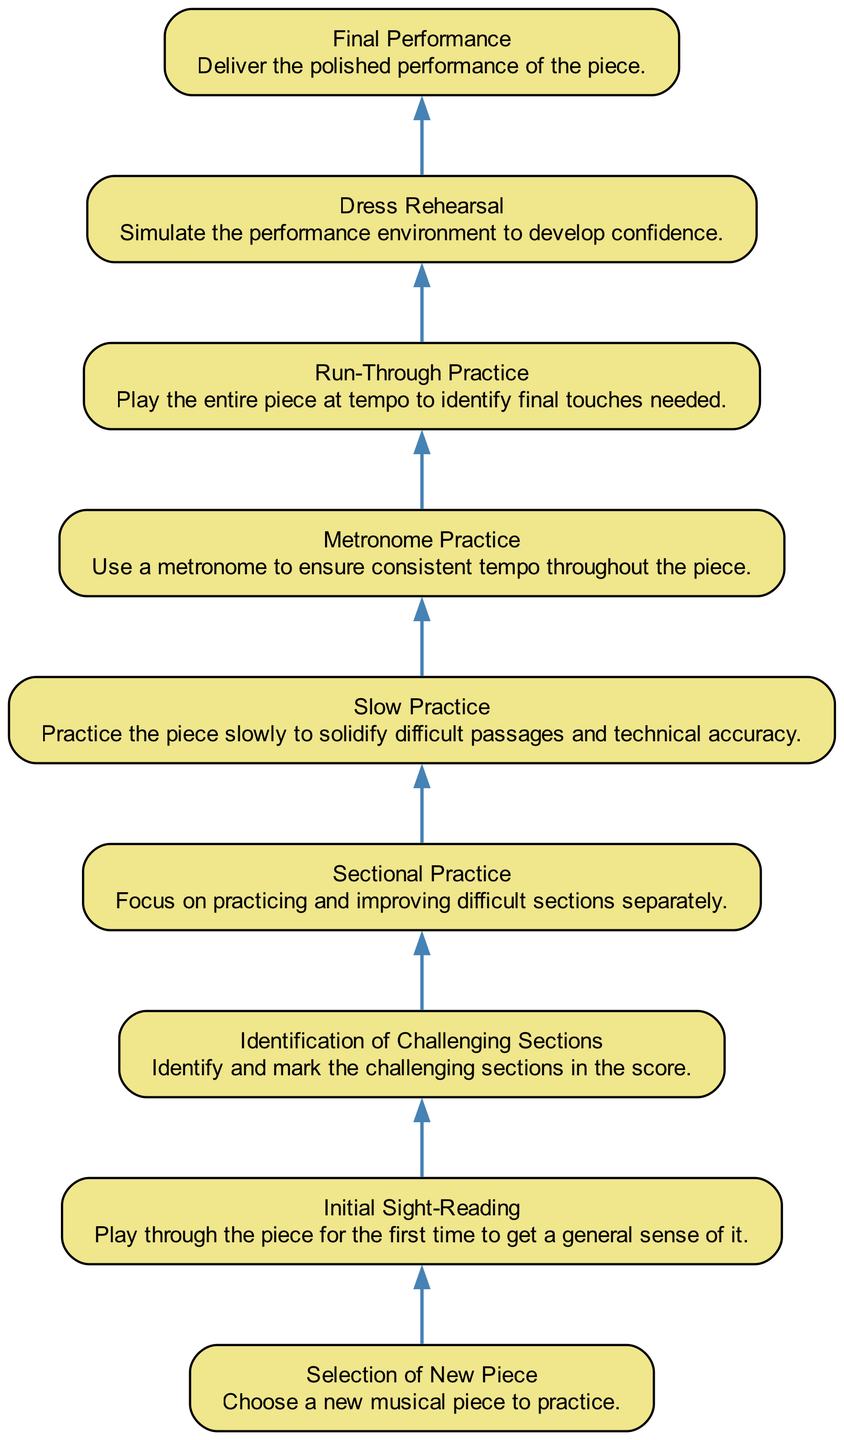What is the first step in the diagram? The first step in the diagram is "Selection of New Piece," as it is the starting node from which the flow begins.
Answer: Selection of New Piece How many nodes are there in the diagram? By counting each unique step in the flowchart, we find there are a total of 8 nodes that represent different stages of practicing the musical piece.
Answer: 8 What is the last step before the "Final Performance"? The last step before reaching "Final Performance" is "Dress Rehearsal," which prepares the performer to simulate the actual performance environment.
Answer: Dress Rehearsal What step directly follows "Slow Practice"? "Slow Practice" leads directly to "Metronome Practice," indicating that practicing slowly is followed by using a metronome to ensure tempo consistency.
Answer: Metronome Practice Which step focuses on separate sections of the piece? The step that focuses on improving specific parts or sections of the piece is "Sectional Practice," where challenging parts are addressed individually.
Answer: Sectional Practice What is the purpose of the "Identification of Challenging Sections"? The purpose of this step is to help the musician pinpoint and mark the difficulties they face within the score for focused practice.
Answer: Identify and mark challenging sections What is the relationship between "Run-Through Practice" and "Metronome Practice"? "Run-Through Practice" comes after "Metronome Practice," indicating that the musician plays through the entire piece at tempo after practicing with the metronome.
Answer: Sequential Which step emphasizes playing slowly for better technical accuracy? The step that emphasizes slow practice for mastering technique is "Slow Practice," which helps in overcoming technical challenges.
Answer: Slow Practice What step confirms the overall readiness before the final performance? The step that confirms readiness before the final performance is "Dress Rehearsal," which acts as a full simulation to boost confidence.
Answer: Dress Rehearsal 